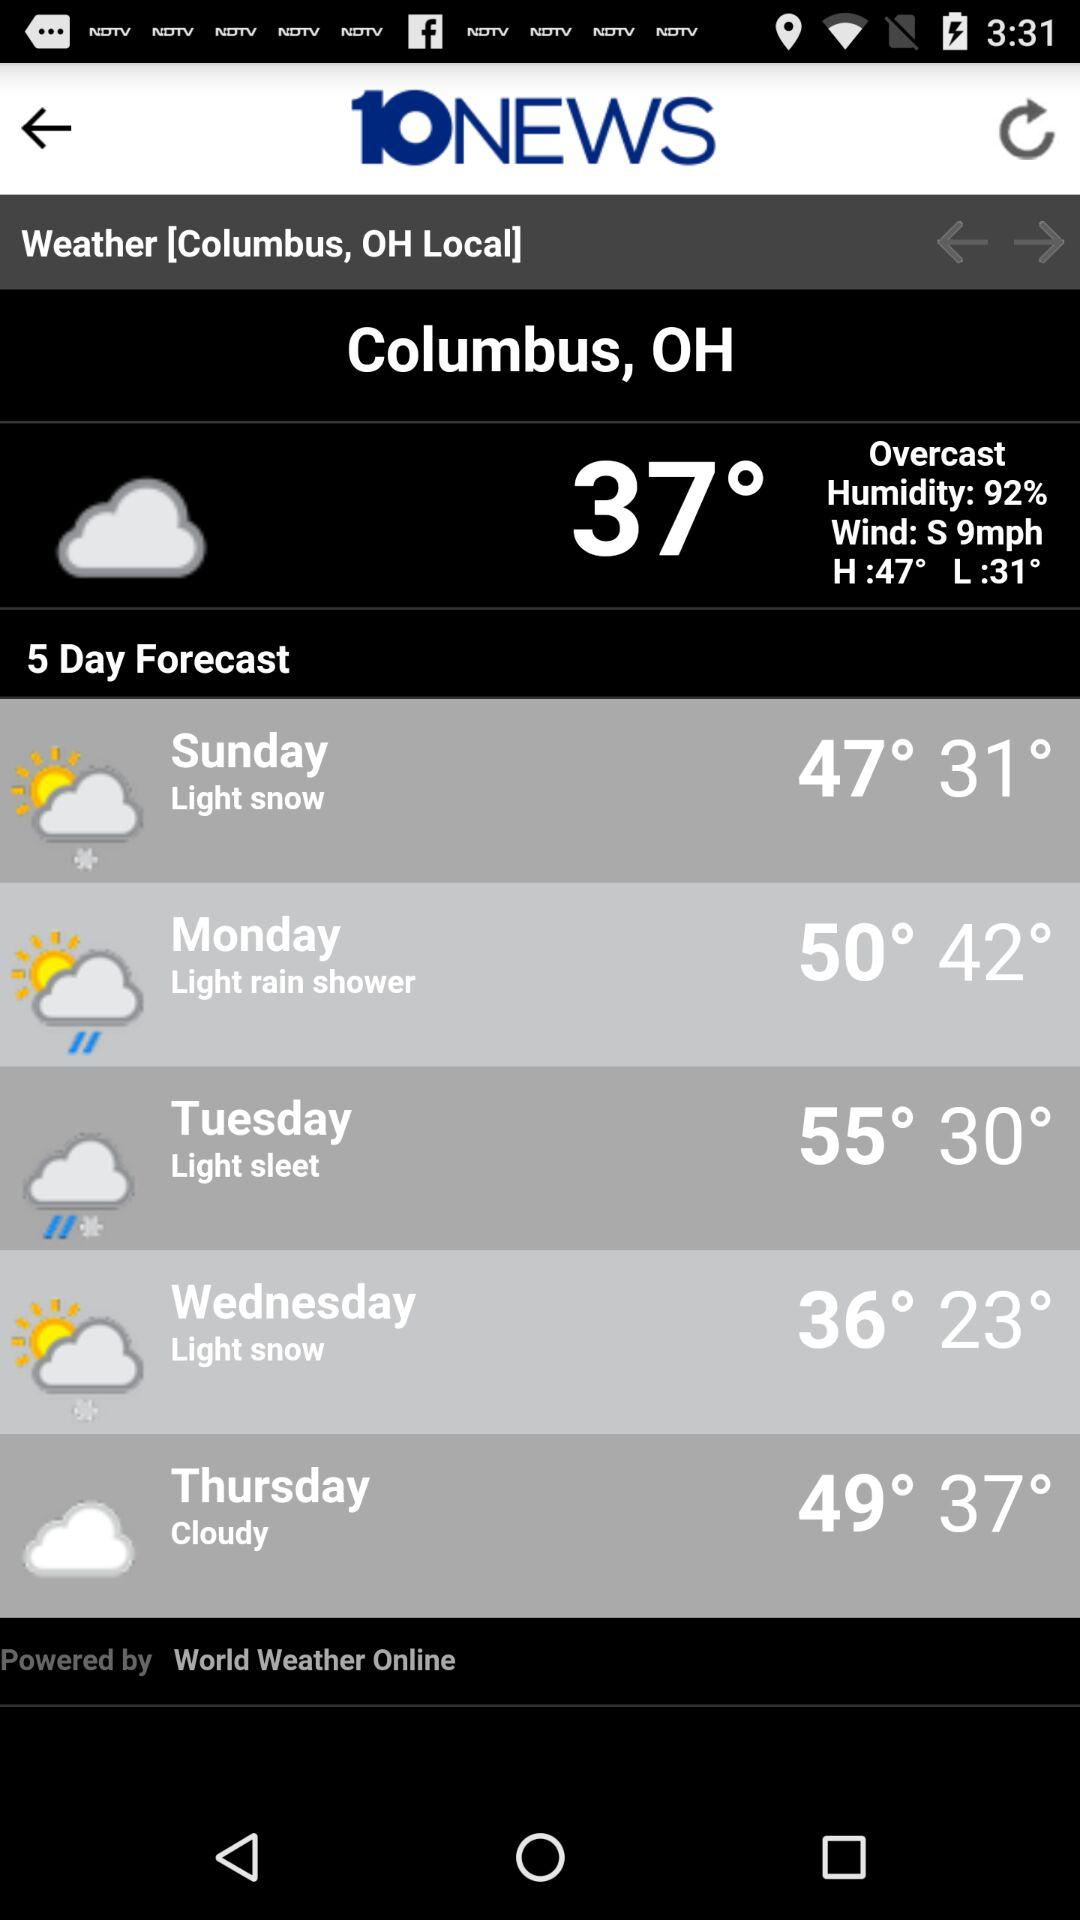Is there any snow predicted for this week? Yes, light snow is predicted for both Sunday and Wednesday, as shown in the 5-day weather forecast. 